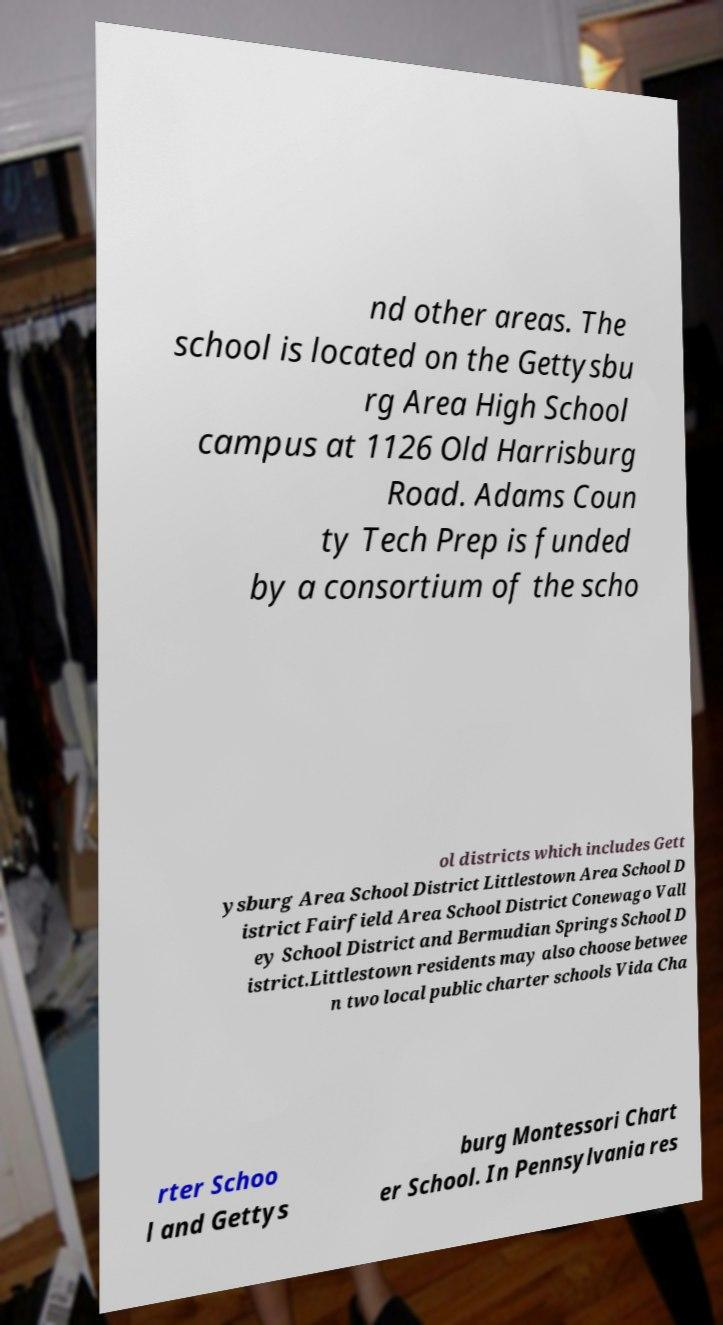What messages or text are displayed in this image? I need them in a readable, typed format. nd other areas. The school is located on the Gettysbu rg Area High School campus at 1126 Old Harrisburg Road. Adams Coun ty Tech Prep is funded by a consortium of the scho ol districts which includes Gett ysburg Area School District Littlestown Area School D istrict Fairfield Area School District Conewago Vall ey School District and Bermudian Springs School D istrict.Littlestown residents may also choose betwee n two local public charter schools Vida Cha rter Schoo l and Gettys burg Montessori Chart er School. In Pennsylvania res 